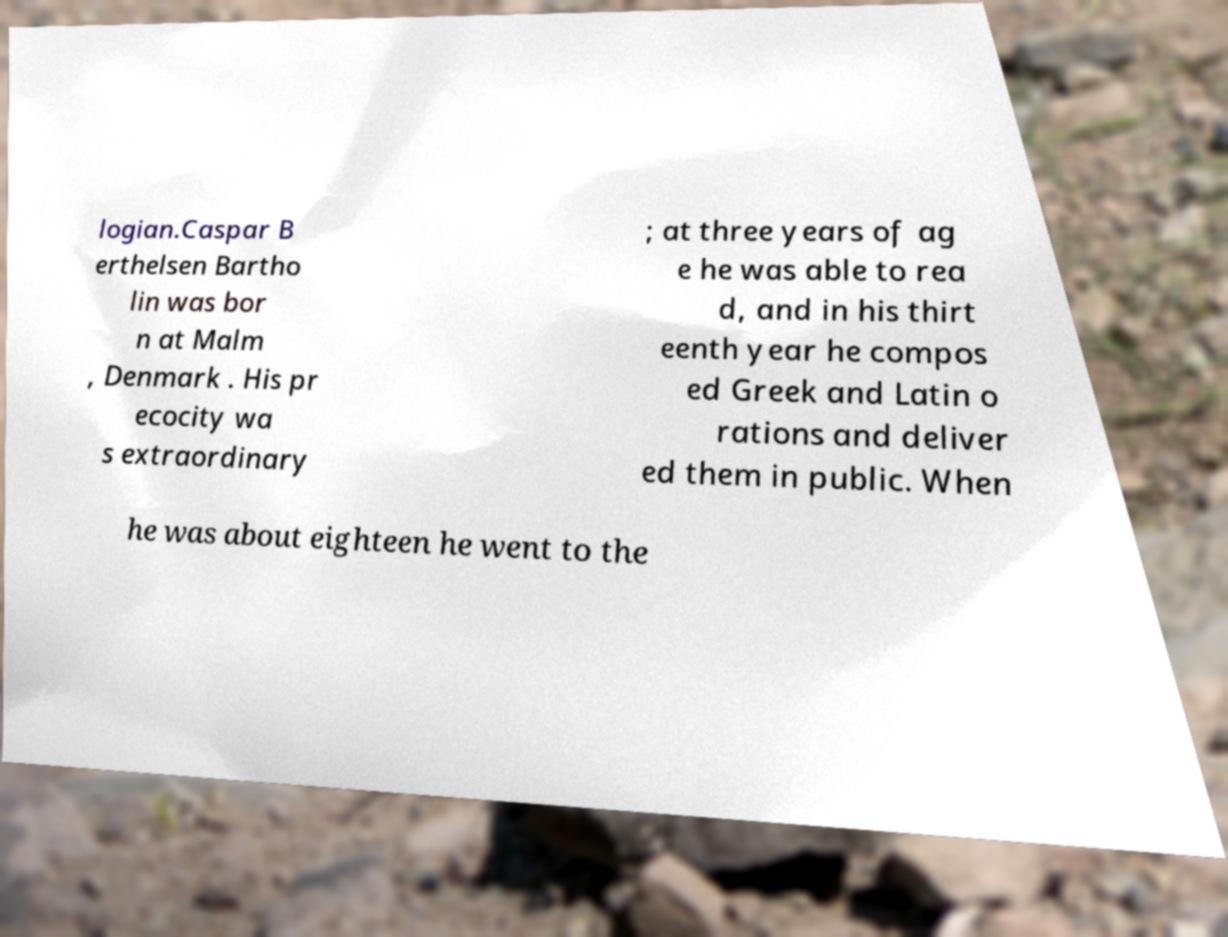Could you assist in decoding the text presented in this image and type it out clearly? logian.Caspar B erthelsen Bartho lin was bor n at Malm , Denmark . His pr ecocity wa s extraordinary ; at three years of ag e he was able to rea d, and in his thirt eenth year he compos ed Greek and Latin o rations and deliver ed them in public. When he was about eighteen he went to the 